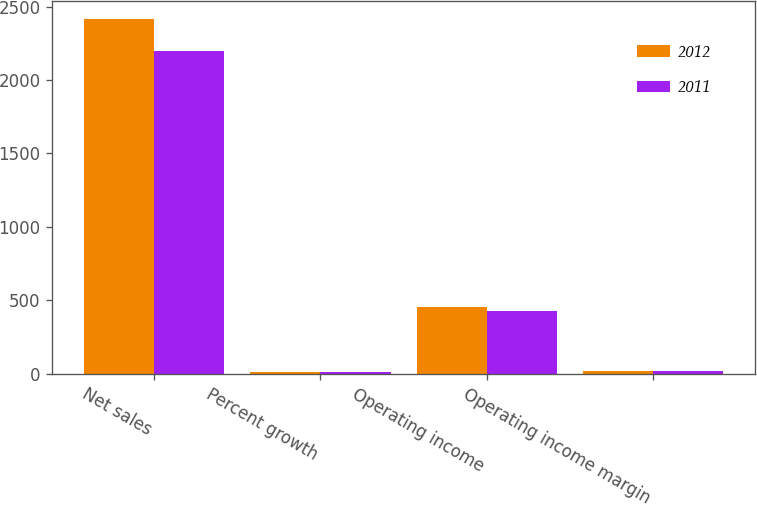Convert chart to OTSL. <chart><loc_0><loc_0><loc_500><loc_500><stacked_bar_chart><ecel><fcel>Net sales<fcel>Percent growth<fcel>Operating income<fcel>Operating income margin<nl><fcel>2012<fcel>2415.3<fcel>9.8<fcel>456.1<fcel>18.9<nl><fcel>2011<fcel>2199.9<fcel>10<fcel>428.4<fcel>19.5<nl></chart> 